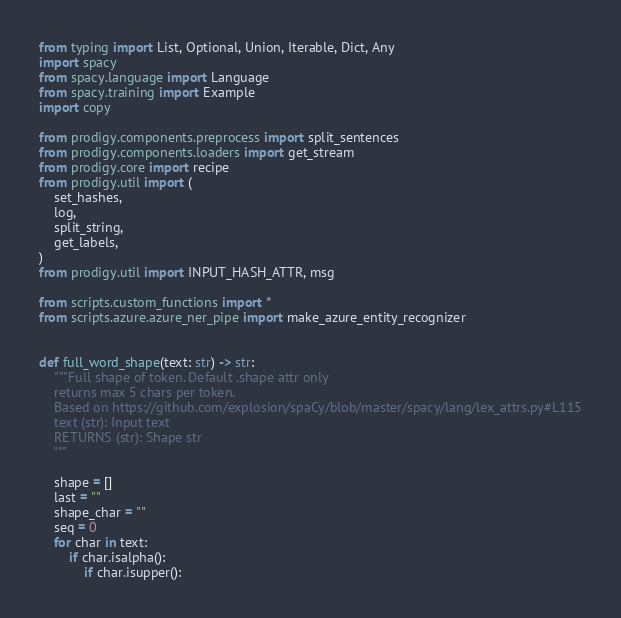<code> <loc_0><loc_0><loc_500><loc_500><_Python_>from typing import List, Optional, Union, Iterable, Dict, Any
import spacy
from spacy.language import Language
from spacy.training import Example
import copy

from prodigy.components.preprocess import split_sentences
from prodigy.components.loaders import get_stream
from prodigy.core import recipe
from prodigy.util import (
    set_hashes,
    log,
    split_string,
    get_labels,
)
from prodigy.util import INPUT_HASH_ATTR, msg

from scripts.custom_functions import *
from scripts.azure.azure_ner_pipe import make_azure_entity_recognizer


def full_word_shape(text: str) -> str:
    """Full shape of token. Default .shape attr only
    returns max 5 chars per token.
    Based on https://github.com/explosion/spaCy/blob/master/spacy/lang/lex_attrs.py#L115
    text (str): Input text
    RETURNS (str): Shape str
    """

    shape = []
    last = ""
    shape_char = ""
    seq = 0
    for char in text:
        if char.isalpha():
            if char.isupper():</code> 